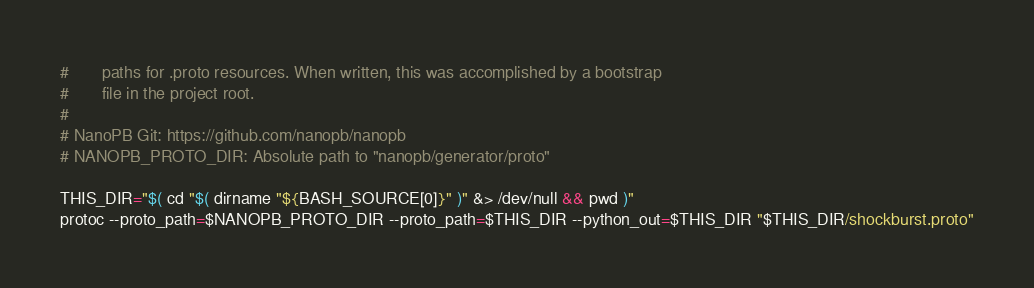Convert code to text. <code><loc_0><loc_0><loc_500><loc_500><_Bash_>#       paths for .proto resources. When written, this was accomplished by a bootstrap
#       file in the project root.
#
# NanoPB Git: https://github.com/nanopb/nanopb
# NANOPB_PROTO_DIR: Absolute path to "nanopb/generator/proto"

THIS_DIR="$( cd "$( dirname "${BASH_SOURCE[0]}" )" &> /dev/null && pwd )"
protoc --proto_path=$NANOPB_PROTO_DIR --proto_path=$THIS_DIR --python_out=$THIS_DIR "$THIS_DIR/shockburst.proto"</code> 